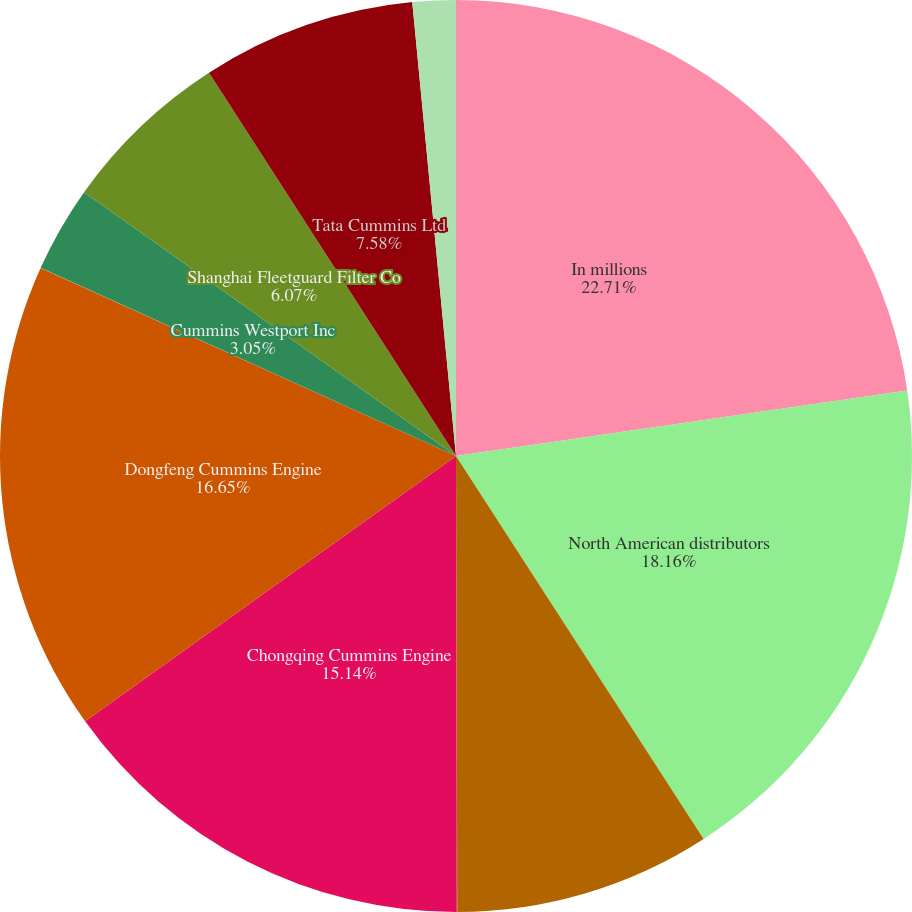Convert chart to OTSL. <chart><loc_0><loc_0><loc_500><loc_500><pie_chart><fcel>In millions<fcel>North American distributors<fcel>Komatsu Cummins Chile Ltda<fcel>All other distributors<fcel>Chongqing Cummins Engine<fcel>Dongfeng Cummins Engine<fcel>Cummins Westport Inc<fcel>Shanghai Fleetguard Filter Co<fcel>Tata Cummins Ltd<fcel>Valvoline Cummins Ltd<nl><fcel>22.7%<fcel>18.16%<fcel>9.09%<fcel>0.02%<fcel>15.14%<fcel>16.65%<fcel>3.05%<fcel>6.07%<fcel>7.58%<fcel>1.53%<nl></chart> 